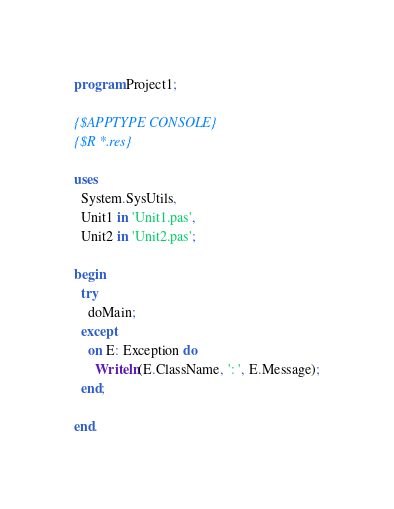<code> <loc_0><loc_0><loc_500><loc_500><_Pascal_>program Project1;

{$APPTYPE CONSOLE}
{$R *.res}

uses
  System.SysUtils,
  Unit1 in 'Unit1.pas',
  Unit2 in 'Unit2.pas';

begin
  try
    doMain;
  except
    on E: Exception do
      Writeln(E.ClassName, ': ', E.Message);
  end;

end.
</code> 